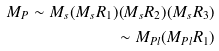Convert formula to latex. <formula><loc_0><loc_0><loc_500><loc_500>M _ { P } \sim M _ { s } ( M _ { s } R _ { 1 } ) ( M _ { s } R _ { 2 } ) ( M _ { s } R _ { 3 } ) \\ \sim M _ { P l } ( M _ { P l } R _ { 1 } )</formula> 